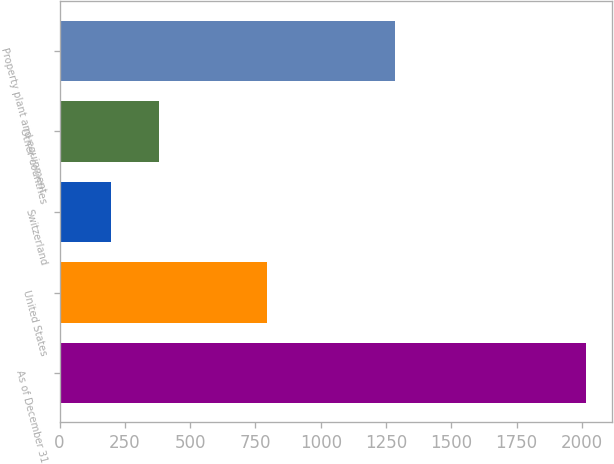Convert chart. <chart><loc_0><loc_0><loc_500><loc_500><bar_chart><fcel>As of December 31<fcel>United States<fcel>Switzerland<fcel>Other countries<fcel>Property plant and equipment<nl><fcel>2014<fcel>794.4<fcel>198.7<fcel>380.23<fcel>1285.3<nl></chart> 